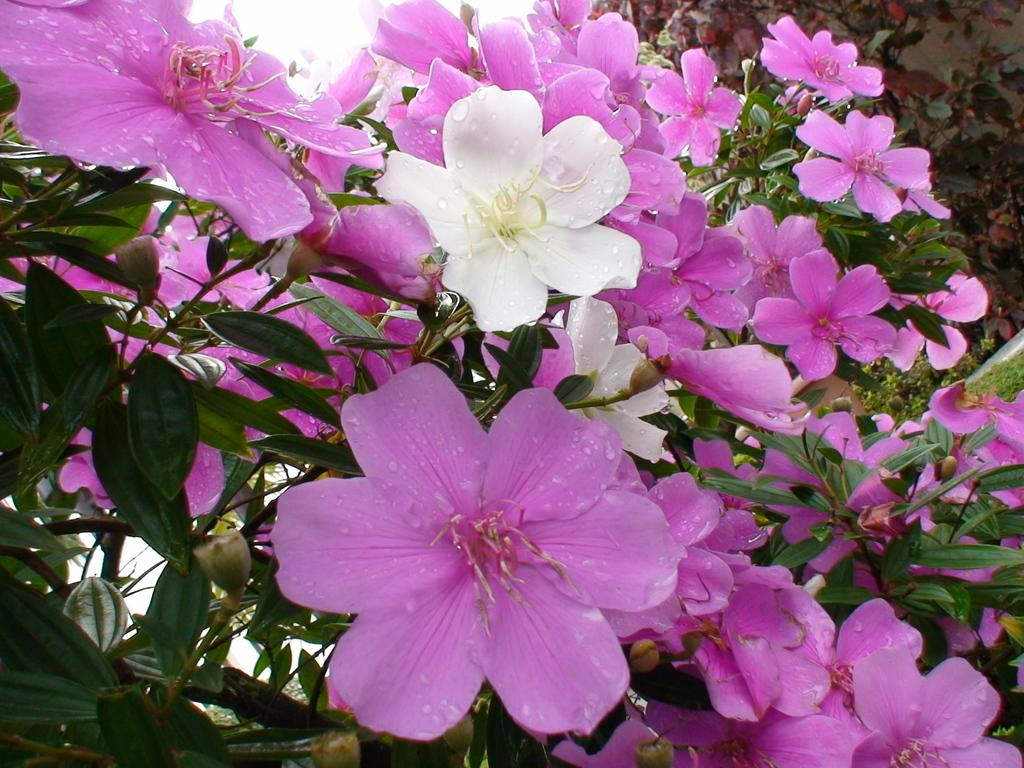What colors are the flowers on the plants in the image? The flowers on the plants are pink and white. Can you describe any additional features of the flowers? Yes, there are water drops on the flowers. What can be seen in the background of the image? The sky is visible at the top of the image. What type of education is being offered in the image? There is no indication of education in the image; it features flowers with water drops and a visible sky. How does the love between the flowers manifest in the image? There is no depiction of love between the flowers in the image; it simply shows flowers with water drops and a visible sky. 